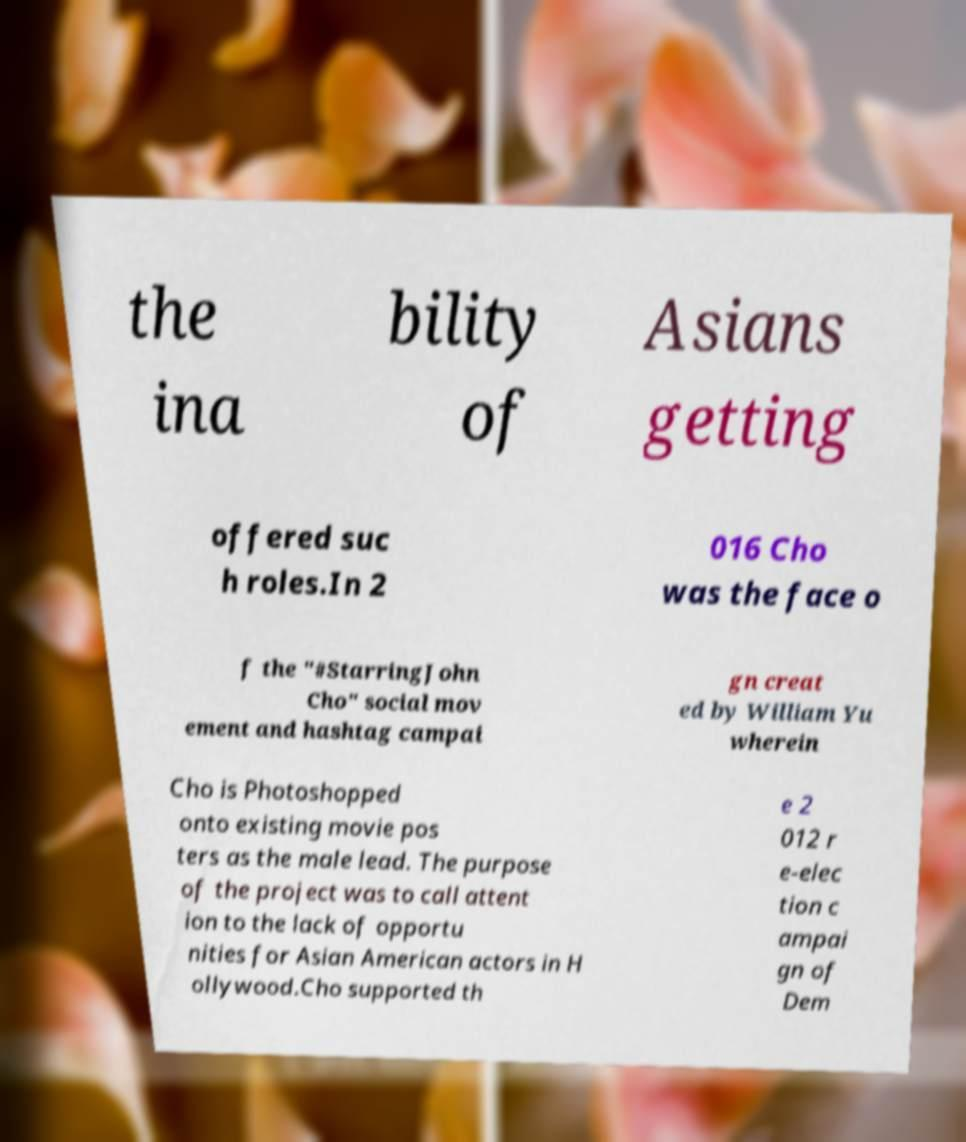For documentation purposes, I need the text within this image transcribed. Could you provide that? the ina bility of Asians getting offered suc h roles.In 2 016 Cho was the face o f the "#StarringJohn Cho" social mov ement and hashtag campai gn creat ed by William Yu wherein Cho is Photoshopped onto existing movie pos ters as the male lead. The purpose of the project was to call attent ion to the lack of opportu nities for Asian American actors in H ollywood.Cho supported th e 2 012 r e-elec tion c ampai gn of Dem 